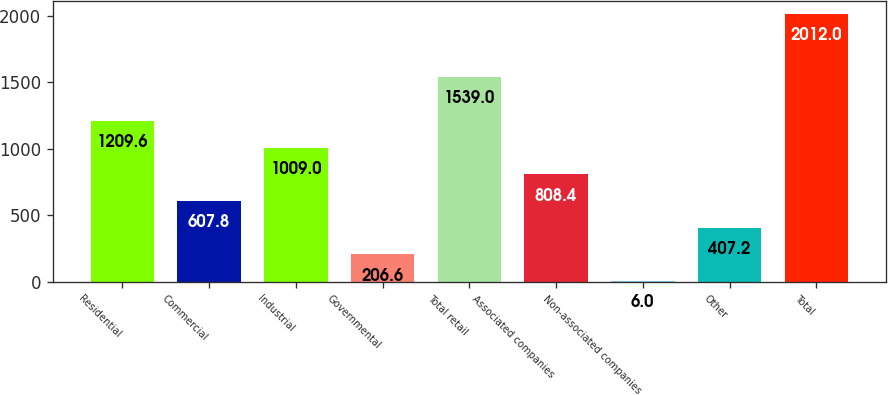Convert chart. <chart><loc_0><loc_0><loc_500><loc_500><bar_chart><fcel>Residential<fcel>Commercial<fcel>Industrial<fcel>Governmental<fcel>Total retail<fcel>Associated companies<fcel>Non-associated companies<fcel>Other<fcel>Total<nl><fcel>1209.6<fcel>607.8<fcel>1009<fcel>206.6<fcel>1539<fcel>808.4<fcel>6<fcel>407.2<fcel>2012<nl></chart> 